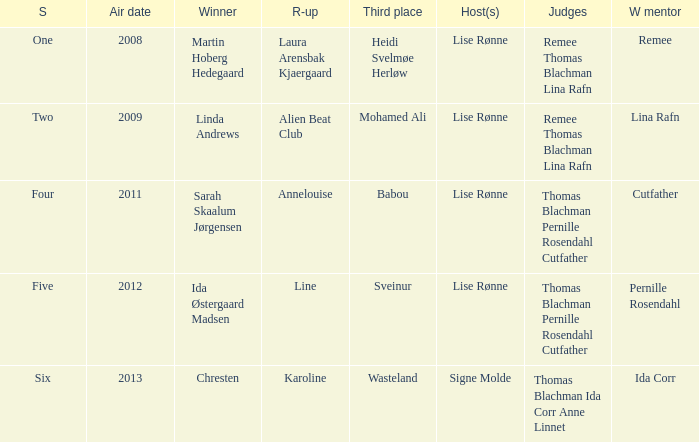Who was the runner-up in season five? Line. 